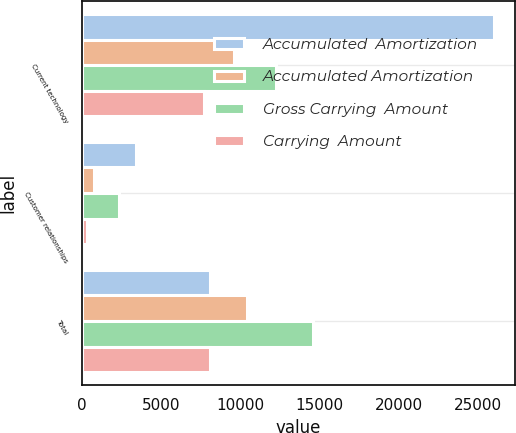Convert chart to OTSL. <chart><loc_0><loc_0><loc_500><loc_500><stacked_bar_chart><ecel><fcel>Current technology<fcel>Customer relationships<fcel>Total<nl><fcel>Accumulated  Amortization<fcel>26011<fcel>3406<fcel>8074<nl><fcel>Accumulated Amortization<fcel>9632<fcel>783<fcel>10415<nl><fcel>Gross Carrying  Amount<fcel>12258<fcel>2333<fcel>14591<nl><fcel>Carrying  Amount<fcel>7746<fcel>328<fcel>8074<nl></chart> 